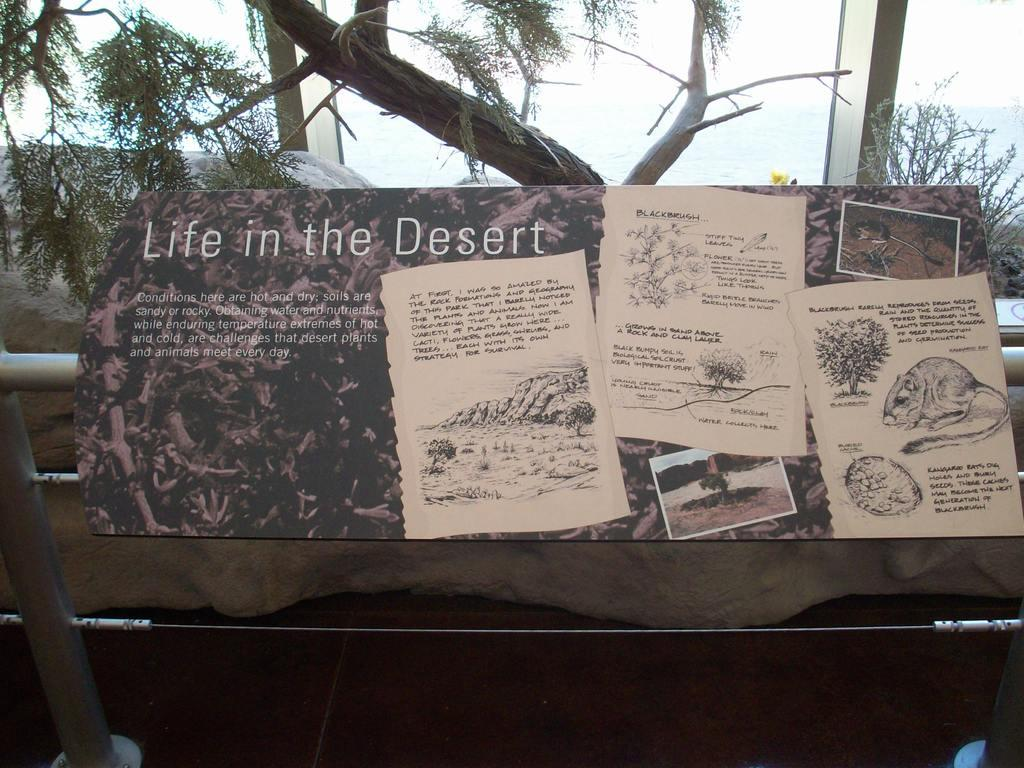What is the main subject of the board in the image? The board has the name "Life in the Desert" on it. What type of information can be found on the board? There are articles posted on the board. What can be seen in the background of the image? There are trees and a pole in the background of the image. What type of sugar is being used to sweeten the wine in the image? There is no sugar or wine present in the image; it features a board with articles and a background with trees and a pole. Is there a coat visible on the board in the image? No, there is no coat visible on the board or anywhere else in the image. 